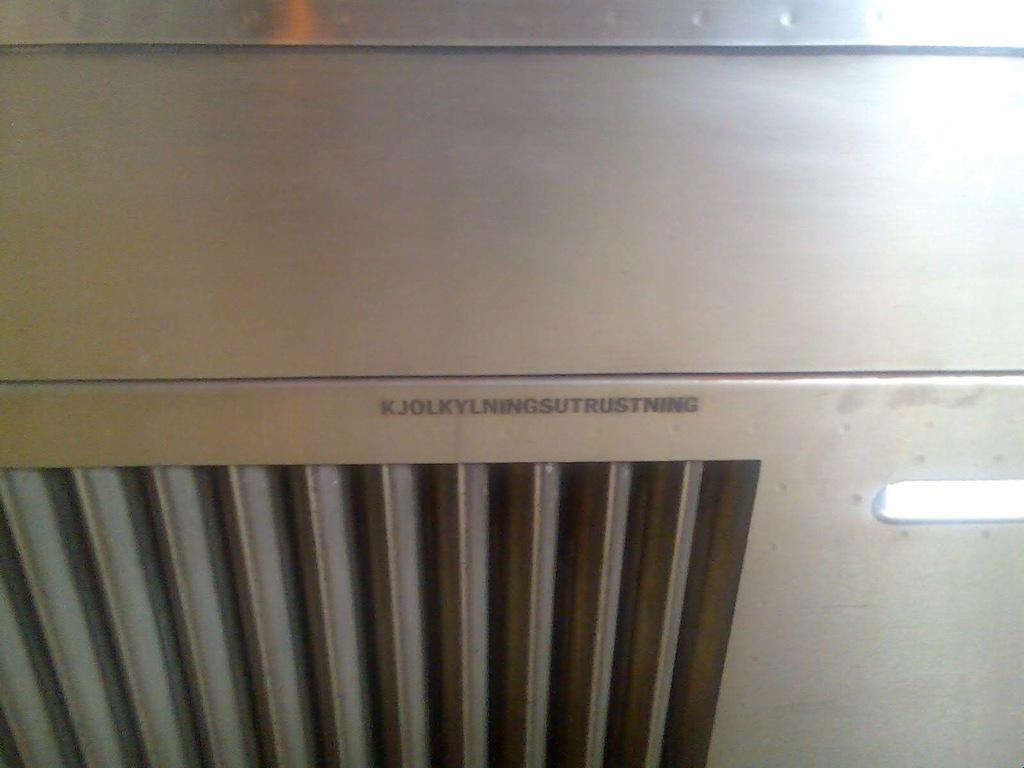<image>
Render a clear and concise summary of the photo. A vent of some sort with the text "KJOLKYLNINGSUTRUSTNING" on it. 